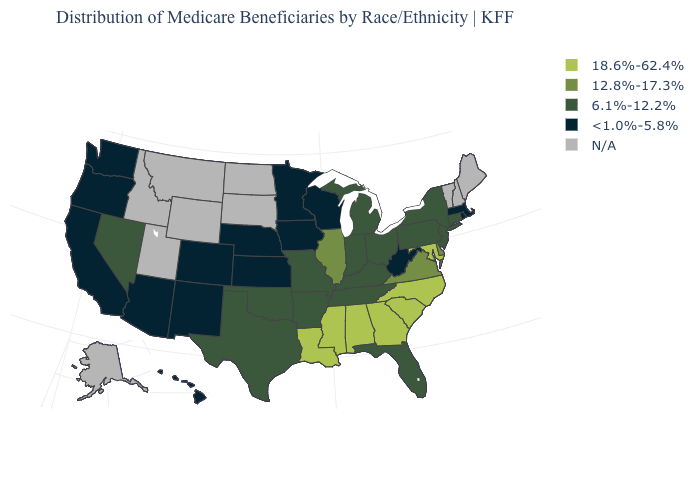Name the states that have a value in the range 6.1%-12.2%?
Quick response, please. Arkansas, Connecticut, Florida, Indiana, Kentucky, Michigan, Missouri, Nevada, New Jersey, New York, Ohio, Oklahoma, Pennsylvania, Tennessee, Texas. What is the value of Colorado?
Quick response, please. <1.0%-5.8%. Name the states that have a value in the range N/A?
Write a very short answer. Alaska, Idaho, Maine, Montana, New Hampshire, North Dakota, South Dakota, Utah, Vermont, Wyoming. Name the states that have a value in the range 6.1%-12.2%?
Answer briefly. Arkansas, Connecticut, Florida, Indiana, Kentucky, Michigan, Missouri, Nevada, New Jersey, New York, Ohio, Oklahoma, Pennsylvania, Tennessee, Texas. Which states hav the highest value in the MidWest?
Keep it brief. Illinois. Which states have the lowest value in the South?
Write a very short answer. West Virginia. Which states have the highest value in the USA?
Give a very brief answer. Alabama, Georgia, Louisiana, Maryland, Mississippi, North Carolina, South Carolina. How many symbols are there in the legend?
Write a very short answer. 5. What is the value of Missouri?
Give a very brief answer. 6.1%-12.2%. Among the states that border Idaho , which have the lowest value?
Quick response, please. Oregon, Washington. What is the value of Idaho?
Quick response, please. N/A. What is the value of Pennsylvania?
Concise answer only. 6.1%-12.2%. Does New Jersey have the lowest value in the Northeast?
Give a very brief answer. No. What is the value of Hawaii?
Write a very short answer. <1.0%-5.8%. 